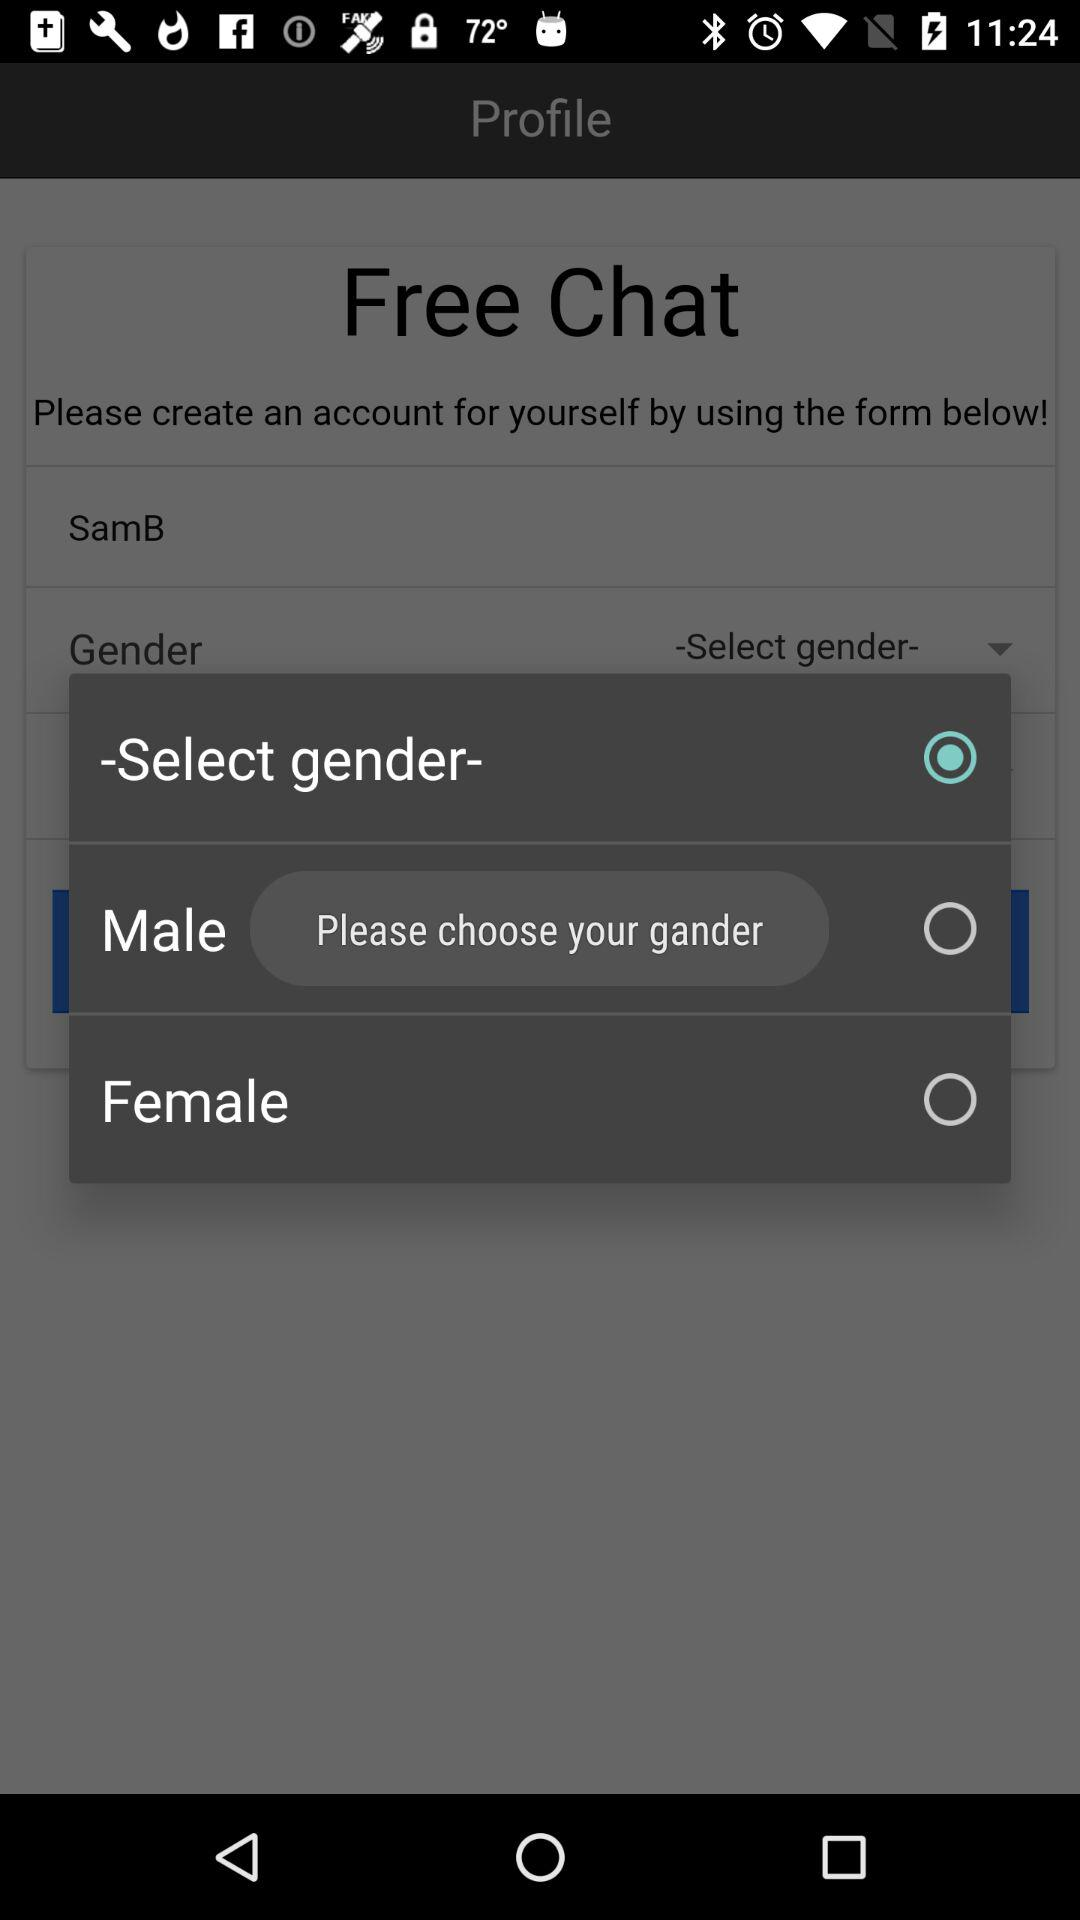What is the given option for gender? The given options are "Male" and "Female". 